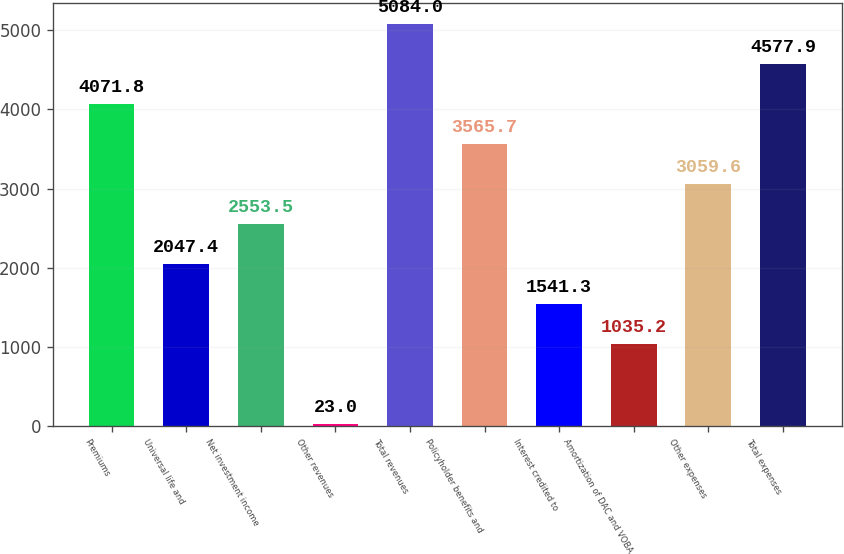Convert chart. <chart><loc_0><loc_0><loc_500><loc_500><bar_chart><fcel>Premiums<fcel>Universal life and<fcel>Net investment income<fcel>Other revenues<fcel>Total revenues<fcel>Policyholder benefits and<fcel>Interest credited to<fcel>Amortization of DAC and VOBA<fcel>Other expenses<fcel>Total expenses<nl><fcel>4071.8<fcel>2047.4<fcel>2553.5<fcel>23<fcel>5084<fcel>3565.7<fcel>1541.3<fcel>1035.2<fcel>3059.6<fcel>4577.9<nl></chart> 